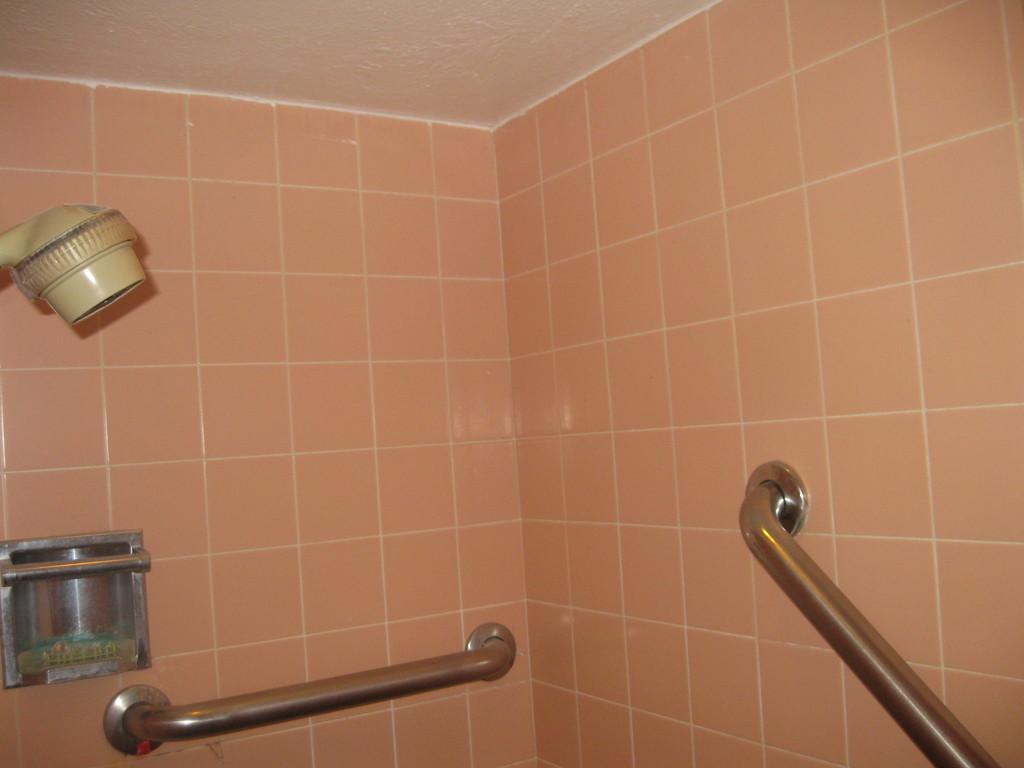Could you give a brief overview of what you see in this image? There are metal objects attached to the wall as we can see at the bottom of this image. 